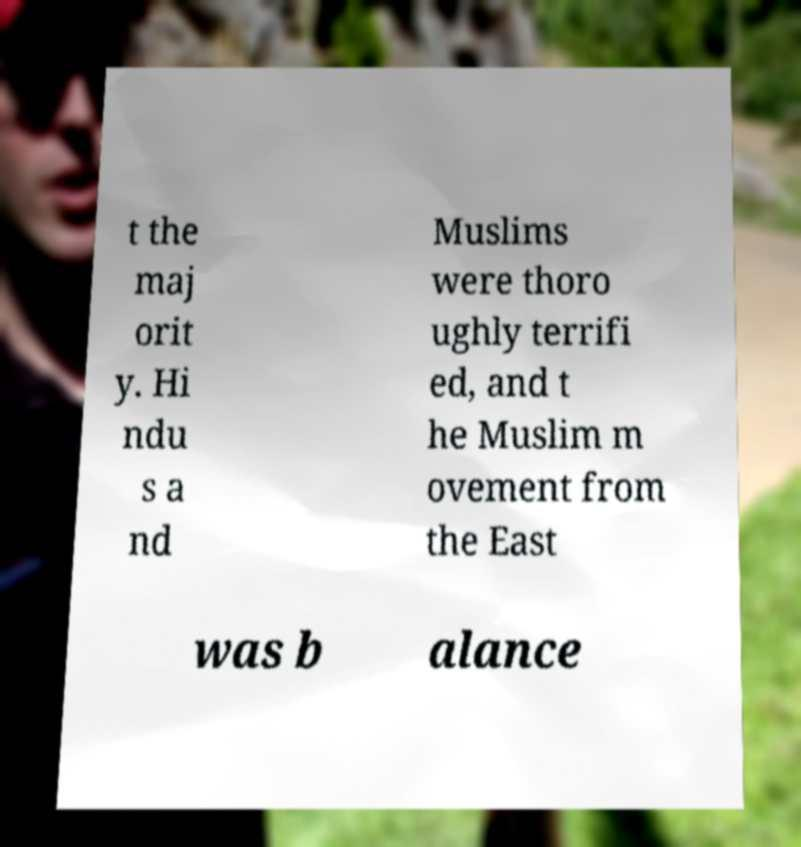Could you assist in decoding the text presented in this image and type it out clearly? t the maj orit y. Hi ndu s a nd Muslims were thoro ughly terrifi ed, and t he Muslim m ovement from the East was b alance 